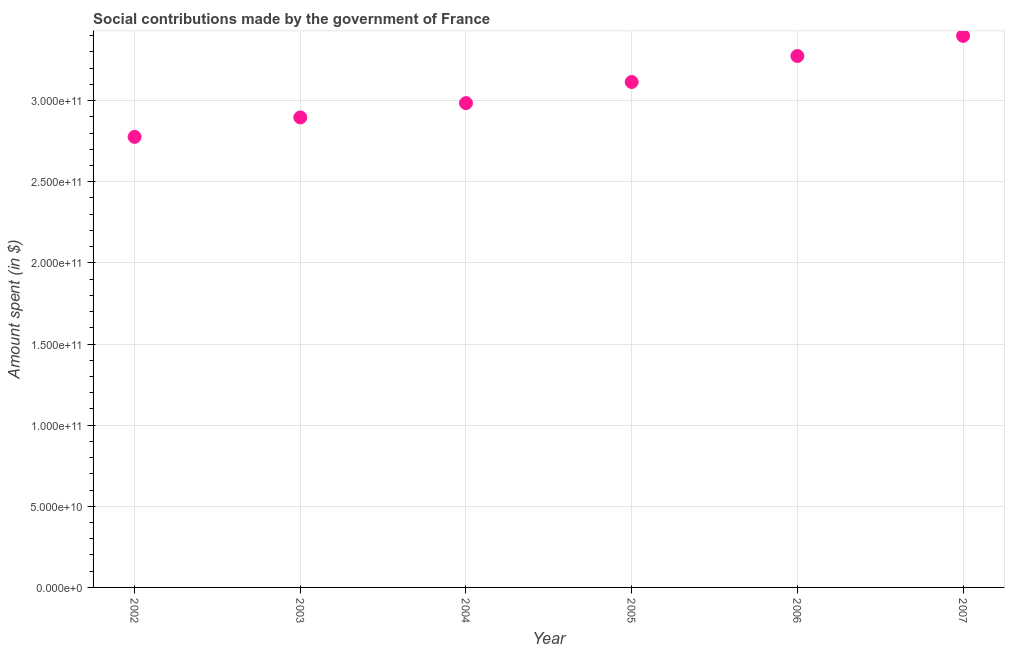What is the amount spent in making social contributions in 2005?
Your answer should be compact. 3.11e+11. Across all years, what is the maximum amount spent in making social contributions?
Give a very brief answer. 3.40e+11. Across all years, what is the minimum amount spent in making social contributions?
Provide a succinct answer. 2.78e+11. In which year was the amount spent in making social contributions maximum?
Make the answer very short. 2007. What is the sum of the amount spent in making social contributions?
Make the answer very short. 1.84e+12. What is the difference between the amount spent in making social contributions in 2002 and 2007?
Your response must be concise. -6.22e+1. What is the average amount spent in making social contributions per year?
Provide a succinct answer. 3.07e+11. What is the median amount spent in making social contributions?
Give a very brief answer. 3.05e+11. Do a majority of the years between 2006 and 2004 (inclusive) have amount spent in making social contributions greater than 100000000000 $?
Ensure brevity in your answer.  No. What is the ratio of the amount spent in making social contributions in 2004 to that in 2006?
Provide a succinct answer. 0.91. What is the difference between the highest and the second highest amount spent in making social contributions?
Provide a succinct answer. 1.24e+1. What is the difference between the highest and the lowest amount spent in making social contributions?
Offer a terse response. 6.22e+1. In how many years, is the amount spent in making social contributions greater than the average amount spent in making social contributions taken over all years?
Ensure brevity in your answer.  3. How many dotlines are there?
Provide a short and direct response. 1. How many years are there in the graph?
Give a very brief answer. 6. What is the difference between two consecutive major ticks on the Y-axis?
Provide a short and direct response. 5.00e+1. Does the graph contain grids?
Your answer should be compact. Yes. What is the title of the graph?
Offer a terse response. Social contributions made by the government of France. What is the label or title of the Y-axis?
Provide a short and direct response. Amount spent (in $). What is the Amount spent (in $) in 2002?
Your answer should be compact. 2.78e+11. What is the Amount spent (in $) in 2003?
Your answer should be compact. 2.90e+11. What is the Amount spent (in $) in 2004?
Provide a succinct answer. 2.98e+11. What is the Amount spent (in $) in 2005?
Make the answer very short. 3.11e+11. What is the Amount spent (in $) in 2006?
Your response must be concise. 3.27e+11. What is the Amount spent (in $) in 2007?
Your answer should be very brief. 3.40e+11. What is the difference between the Amount spent (in $) in 2002 and 2003?
Offer a very short reply. -1.20e+1. What is the difference between the Amount spent (in $) in 2002 and 2004?
Offer a very short reply. -2.08e+1. What is the difference between the Amount spent (in $) in 2002 and 2005?
Give a very brief answer. -3.38e+1. What is the difference between the Amount spent (in $) in 2002 and 2006?
Ensure brevity in your answer.  -4.98e+1. What is the difference between the Amount spent (in $) in 2002 and 2007?
Your response must be concise. -6.22e+1. What is the difference between the Amount spent (in $) in 2003 and 2004?
Your answer should be very brief. -8.82e+09. What is the difference between the Amount spent (in $) in 2003 and 2005?
Provide a succinct answer. -2.18e+1. What is the difference between the Amount spent (in $) in 2003 and 2006?
Make the answer very short. -3.78e+1. What is the difference between the Amount spent (in $) in 2003 and 2007?
Give a very brief answer. -5.03e+1. What is the difference between the Amount spent (in $) in 2004 and 2005?
Offer a very short reply. -1.30e+1. What is the difference between the Amount spent (in $) in 2004 and 2006?
Your response must be concise. -2.90e+1. What is the difference between the Amount spent (in $) in 2004 and 2007?
Make the answer very short. -4.14e+1. What is the difference between the Amount spent (in $) in 2005 and 2006?
Offer a terse response. -1.60e+1. What is the difference between the Amount spent (in $) in 2005 and 2007?
Ensure brevity in your answer.  -2.84e+1. What is the difference between the Amount spent (in $) in 2006 and 2007?
Offer a terse response. -1.24e+1. What is the ratio of the Amount spent (in $) in 2002 to that in 2004?
Offer a terse response. 0.93. What is the ratio of the Amount spent (in $) in 2002 to that in 2005?
Provide a short and direct response. 0.89. What is the ratio of the Amount spent (in $) in 2002 to that in 2006?
Offer a terse response. 0.85. What is the ratio of the Amount spent (in $) in 2002 to that in 2007?
Your response must be concise. 0.82. What is the ratio of the Amount spent (in $) in 2003 to that in 2004?
Your response must be concise. 0.97. What is the ratio of the Amount spent (in $) in 2003 to that in 2006?
Keep it short and to the point. 0.88. What is the ratio of the Amount spent (in $) in 2003 to that in 2007?
Make the answer very short. 0.85. What is the ratio of the Amount spent (in $) in 2004 to that in 2005?
Give a very brief answer. 0.96. What is the ratio of the Amount spent (in $) in 2004 to that in 2006?
Provide a short and direct response. 0.91. What is the ratio of the Amount spent (in $) in 2004 to that in 2007?
Provide a short and direct response. 0.88. What is the ratio of the Amount spent (in $) in 2005 to that in 2006?
Provide a short and direct response. 0.95. What is the ratio of the Amount spent (in $) in 2005 to that in 2007?
Provide a succinct answer. 0.92. 